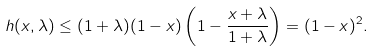Convert formula to latex. <formula><loc_0><loc_0><loc_500><loc_500>h ( x , \lambda ) \leq ( 1 + \lambda ) ( 1 - x ) \left ( 1 - \frac { x + \lambda } { 1 + \lambda } \right ) = ( 1 - x ) ^ { 2 } .</formula> 